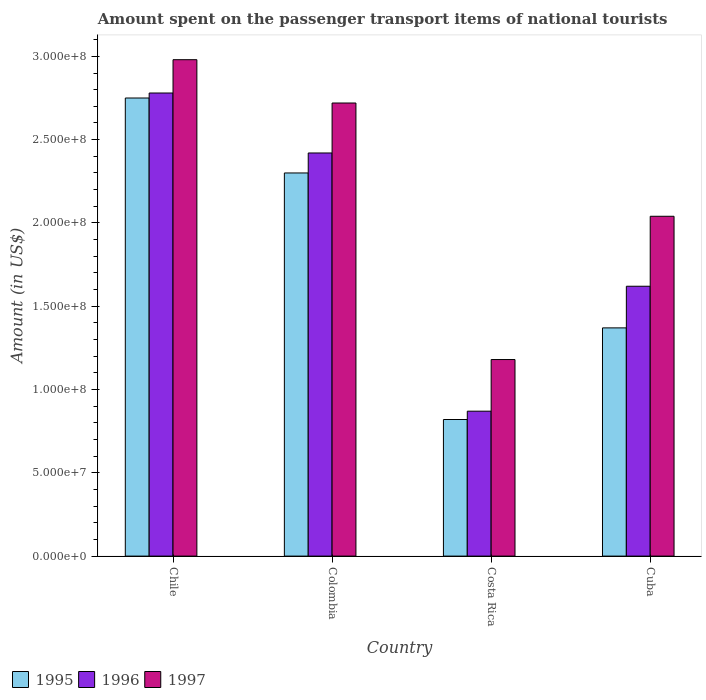How many different coloured bars are there?
Give a very brief answer. 3. How many groups of bars are there?
Make the answer very short. 4. Are the number of bars per tick equal to the number of legend labels?
Make the answer very short. Yes. How many bars are there on the 2nd tick from the left?
Keep it short and to the point. 3. How many bars are there on the 1st tick from the right?
Your answer should be very brief. 3. What is the amount spent on the passenger transport items of national tourists in 1997 in Chile?
Provide a short and direct response. 2.98e+08. Across all countries, what is the maximum amount spent on the passenger transport items of national tourists in 1996?
Your answer should be compact. 2.78e+08. Across all countries, what is the minimum amount spent on the passenger transport items of national tourists in 1995?
Offer a terse response. 8.20e+07. What is the total amount spent on the passenger transport items of national tourists in 1995 in the graph?
Keep it short and to the point. 7.24e+08. What is the difference between the amount spent on the passenger transport items of national tourists in 1995 in Chile and that in Cuba?
Make the answer very short. 1.38e+08. What is the difference between the amount spent on the passenger transport items of national tourists in 1996 in Costa Rica and the amount spent on the passenger transport items of national tourists in 1997 in Cuba?
Your response must be concise. -1.17e+08. What is the average amount spent on the passenger transport items of national tourists in 1996 per country?
Make the answer very short. 1.92e+08. What is the difference between the amount spent on the passenger transport items of national tourists of/in 1997 and amount spent on the passenger transport items of national tourists of/in 1995 in Costa Rica?
Your answer should be very brief. 3.60e+07. In how many countries, is the amount spent on the passenger transport items of national tourists in 1996 greater than 210000000 US$?
Ensure brevity in your answer.  2. What is the ratio of the amount spent on the passenger transport items of national tourists in 1996 in Chile to that in Cuba?
Offer a terse response. 1.72. Is the difference between the amount spent on the passenger transport items of national tourists in 1997 in Costa Rica and Cuba greater than the difference between the amount spent on the passenger transport items of national tourists in 1995 in Costa Rica and Cuba?
Provide a succinct answer. No. What is the difference between the highest and the second highest amount spent on the passenger transport items of national tourists in 1996?
Provide a short and direct response. 1.16e+08. What is the difference between the highest and the lowest amount spent on the passenger transport items of national tourists in 1996?
Keep it short and to the point. 1.91e+08. Is the sum of the amount spent on the passenger transport items of national tourists in 1997 in Chile and Cuba greater than the maximum amount spent on the passenger transport items of national tourists in 1995 across all countries?
Your response must be concise. Yes. How many bars are there?
Ensure brevity in your answer.  12. Are all the bars in the graph horizontal?
Your answer should be very brief. No. What is the difference between two consecutive major ticks on the Y-axis?
Make the answer very short. 5.00e+07. Does the graph contain grids?
Your response must be concise. No. What is the title of the graph?
Provide a succinct answer. Amount spent on the passenger transport items of national tourists. What is the label or title of the Y-axis?
Keep it short and to the point. Amount (in US$). What is the Amount (in US$) in 1995 in Chile?
Offer a very short reply. 2.75e+08. What is the Amount (in US$) in 1996 in Chile?
Make the answer very short. 2.78e+08. What is the Amount (in US$) of 1997 in Chile?
Make the answer very short. 2.98e+08. What is the Amount (in US$) of 1995 in Colombia?
Keep it short and to the point. 2.30e+08. What is the Amount (in US$) in 1996 in Colombia?
Offer a terse response. 2.42e+08. What is the Amount (in US$) of 1997 in Colombia?
Your answer should be very brief. 2.72e+08. What is the Amount (in US$) of 1995 in Costa Rica?
Offer a terse response. 8.20e+07. What is the Amount (in US$) of 1996 in Costa Rica?
Keep it short and to the point. 8.70e+07. What is the Amount (in US$) in 1997 in Costa Rica?
Give a very brief answer. 1.18e+08. What is the Amount (in US$) of 1995 in Cuba?
Make the answer very short. 1.37e+08. What is the Amount (in US$) of 1996 in Cuba?
Your response must be concise. 1.62e+08. What is the Amount (in US$) of 1997 in Cuba?
Your answer should be compact. 2.04e+08. Across all countries, what is the maximum Amount (in US$) in 1995?
Ensure brevity in your answer.  2.75e+08. Across all countries, what is the maximum Amount (in US$) of 1996?
Ensure brevity in your answer.  2.78e+08. Across all countries, what is the maximum Amount (in US$) in 1997?
Keep it short and to the point. 2.98e+08. Across all countries, what is the minimum Amount (in US$) in 1995?
Provide a succinct answer. 8.20e+07. Across all countries, what is the minimum Amount (in US$) in 1996?
Offer a very short reply. 8.70e+07. Across all countries, what is the minimum Amount (in US$) of 1997?
Keep it short and to the point. 1.18e+08. What is the total Amount (in US$) in 1995 in the graph?
Ensure brevity in your answer.  7.24e+08. What is the total Amount (in US$) of 1996 in the graph?
Keep it short and to the point. 7.69e+08. What is the total Amount (in US$) in 1997 in the graph?
Your answer should be compact. 8.92e+08. What is the difference between the Amount (in US$) in 1995 in Chile and that in Colombia?
Keep it short and to the point. 4.50e+07. What is the difference between the Amount (in US$) in 1996 in Chile and that in Colombia?
Make the answer very short. 3.60e+07. What is the difference between the Amount (in US$) of 1997 in Chile and that in Colombia?
Your answer should be compact. 2.60e+07. What is the difference between the Amount (in US$) of 1995 in Chile and that in Costa Rica?
Ensure brevity in your answer.  1.93e+08. What is the difference between the Amount (in US$) in 1996 in Chile and that in Costa Rica?
Offer a very short reply. 1.91e+08. What is the difference between the Amount (in US$) of 1997 in Chile and that in Costa Rica?
Ensure brevity in your answer.  1.80e+08. What is the difference between the Amount (in US$) in 1995 in Chile and that in Cuba?
Offer a very short reply. 1.38e+08. What is the difference between the Amount (in US$) in 1996 in Chile and that in Cuba?
Offer a very short reply. 1.16e+08. What is the difference between the Amount (in US$) of 1997 in Chile and that in Cuba?
Make the answer very short. 9.40e+07. What is the difference between the Amount (in US$) in 1995 in Colombia and that in Costa Rica?
Offer a very short reply. 1.48e+08. What is the difference between the Amount (in US$) in 1996 in Colombia and that in Costa Rica?
Offer a very short reply. 1.55e+08. What is the difference between the Amount (in US$) in 1997 in Colombia and that in Costa Rica?
Keep it short and to the point. 1.54e+08. What is the difference between the Amount (in US$) in 1995 in Colombia and that in Cuba?
Provide a short and direct response. 9.30e+07. What is the difference between the Amount (in US$) in 1996 in Colombia and that in Cuba?
Make the answer very short. 8.00e+07. What is the difference between the Amount (in US$) of 1997 in Colombia and that in Cuba?
Your answer should be compact. 6.80e+07. What is the difference between the Amount (in US$) of 1995 in Costa Rica and that in Cuba?
Your response must be concise. -5.50e+07. What is the difference between the Amount (in US$) of 1996 in Costa Rica and that in Cuba?
Make the answer very short. -7.50e+07. What is the difference between the Amount (in US$) of 1997 in Costa Rica and that in Cuba?
Give a very brief answer. -8.60e+07. What is the difference between the Amount (in US$) in 1995 in Chile and the Amount (in US$) in 1996 in Colombia?
Your answer should be compact. 3.30e+07. What is the difference between the Amount (in US$) of 1995 in Chile and the Amount (in US$) of 1997 in Colombia?
Your answer should be very brief. 3.00e+06. What is the difference between the Amount (in US$) of 1996 in Chile and the Amount (in US$) of 1997 in Colombia?
Make the answer very short. 6.00e+06. What is the difference between the Amount (in US$) of 1995 in Chile and the Amount (in US$) of 1996 in Costa Rica?
Ensure brevity in your answer.  1.88e+08. What is the difference between the Amount (in US$) of 1995 in Chile and the Amount (in US$) of 1997 in Costa Rica?
Give a very brief answer. 1.57e+08. What is the difference between the Amount (in US$) of 1996 in Chile and the Amount (in US$) of 1997 in Costa Rica?
Keep it short and to the point. 1.60e+08. What is the difference between the Amount (in US$) in 1995 in Chile and the Amount (in US$) in 1996 in Cuba?
Your answer should be very brief. 1.13e+08. What is the difference between the Amount (in US$) in 1995 in Chile and the Amount (in US$) in 1997 in Cuba?
Provide a short and direct response. 7.10e+07. What is the difference between the Amount (in US$) of 1996 in Chile and the Amount (in US$) of 1997 in Cuba?
Your answer should be compact. 7.40e+07. What is the difference between the Amount (in US$) of 1995 in Colombia and the Amount (in US$) of 1996 in Costa Rica?
Give a very brief answer. 1.43e+08. What is the difference between the Amount (in US$) of 1995 in Colombia and the Amount (in US$) of 1997 in Costa Rica?
Your answer should be compact. 1.12e+08. What is the difference between the Amount (in US$) in 1996 in Colombia and the Amount (in US$) in 1997 in Costa Rica?
Ensure brevity in your answer.  1.24e+08. What is the difference between the Amount (in US$) of 1995 in Colombia and the Amount (in US$) of 1996 in Cuba?
Ensure brevity in your answer.  6.80e+07. What is the difference between the Amount (in US$) in 1995 in Colombia and the Amount (in US$) in 1997 in Cuba?
Keep it short and to the point. 2.60e+07. What is the difference between the Amount (in US$) of 1996 in Colombia and the Amount (in US$) of 1997 in Cuba?
Your answer should be compact. 3.80e+07. What is the difference between the Amount (in US$) of 1995 in Costa Rica and the Amount (in US$) of 1996 in Cuba?
Make the answer very short. -8.00e+07. What is the difference between the Amount (in US$) of 1995 in Costa Rica and the Amount (in US$) of 1997 in Cuba?
Keep it short and to the point. -1.22e+08. What is the difference between the Amount (in US$) of 1996 in Costa Rica and the Amount (in US$) of 1997 in Cuba?
Provide a succinct answer. -1.17e+08. What is the average Amount (in US$) in 1995 per country?
Provide a succinct answer. 1.81e+08. What is the average Amount (in US$) of 1996 per country?
Provide a succinct answer. 1.92e+08. What is the average Amount (in US$) in 1997 per country?
Your response must be concise. 2.23e+08. What is the difference between the Amount (in US$) of 1995 and Amount (in US$) of 1997 in Chile?
Keep it short and to the point. -2.30e+07. What is the difference between the Amount (in US$) of 1996 and Amount (in US$) of 1997 in Chile?
Ensure brevity in your answer.  -2.00e+07. What is the difference between the Amount (in US$) of 1995 and Amount (in US$) of 1996 in Colombia?
Give a very brief answer. -1.20e+07. What is the difference between the Amount (in US$) of 1995 and Amount (in US$) of 1997 in Colombia?
Provide a succinct answer. -4.20e+07. What is the difference between the Amount (in US$) of 1996 and Amount (in US$) of 1997 in Colombia?
Make the answer very short. -3.00e+07. What is the difference between the Amount (in US$) of 1995 and Amount (in US$) of 1996 in Costa Rica?
Ensure brevity in your answer.  -5.00e+06. What is the difference between the Amount (in US$) of 1995 and Amount (in US$) of 1997 in Costa Rica?
Keep it short and to the point. -3.60e+07. What is the difference between the Amount (in US$) in 1996 and Amount (in US$) in 1997 in Costa Rica?
Your answer should be compact. -3.10e+07. What is the difference between the Amount (in US$) in 1995 and Amount (in US$) in 1996 in Cuba?
Offer a terse response. -2.50e+07. What is the difference between the Amount (in US$) of 1995 and Amount (in US$) of 1997 in Cuba?
Offer a terse response. -6.70e+07. What is the difference between the Amount (in US$) in 1996 and Amount (in US$) in 1997 in Cuba?
Your response must be concise. -4.20e+07. What is the ratio of the Amount (in US$) of 1995 in Chile to that in Colombia?
Give a very brief answer. 1.2. What is the ratio of the Amount (in US$) in 1996 in Chile to that in Colombia?
Make the answer very short. 1.15. What is the ratio of the Amount (in US$) in 1997 in Chile to that in Colombia?
Make the answer very short. 1.1. What is the ratio of the Amount (in US$) in 1995 in Chile to that in Costa Rica?
Your response must be concise. 3.35. What is the ratio of the Amount (in US$) of 1996 in Chile to that in Costa Rica?
Ensure brevity in your answer.  3.2. What is the ratio of the Amount (in US$) of 1997 in Chile to that in Costa Rica?
Provide a succinct answer. 2.53. What is the ratio of the Amount (in US$) of 1995 in Chile to that in Cuba?
Provide a short and direct response. 2.01. What is the ratio of the Amount (in US$) of 1996 in Chile to that in Cuba?
Give a very brief answer. 1.72. What is the ratio of the Amount (in US$) of 1997 in Chile to that in Cuba?
Keep it short and to the point. 1.46. What is the ratio of the Amount (in US$) in 1995 in Colombia to that in Costa Rica?
Your answer should be very brief. 2.8. What is the ratio of the Amount (in US$) in 1996 in Colombia to that in Costa Rica?
Give a very brief answer. 2.78. What is the ratio of the Amount (in US$) in 1997 in Colombia to that in Costa Rica?
Ensure brevity in your answer.  2.31. What is the ratio of the Amount (in US$) of 1995 in Colombia to that in Cuba?
Provide a short and direct response. 1.68. What is the ratio of the Amount (in US$) in 1996 in Colombia to that in Cuba?
Make the answer very short. 1.49. What is the ratio of the Amount (in US$) of 1995 in Costa Rica to that in Cuba?
Your answer should be compact. 0.6. What is the ratio of the Amount (in US$) in 1996 in Costa Rica to that in Cuba?
Provide a succinct answer. 0.54. What is the ratio of the Amount (in US$) in 1997 in Costa Rica to that in Cuba?
Give a very brief answer. 0.58. What is the difference between the highest and the second highest Amount (in US$) in 1995?
Offer a very short reply. 4.50e+07. What is the difference between the highest and the second highest Amount (in US$) of 1996?
Your response must be concise. 3.60e+07. What is the difference between the highest and the second highest Amount (in US$) in 1997?
Offer a terse response. 2.60e+07. What is the difference between the highest and the lowest Amount (in US$) in 1995?
Provide a short and direct response. 1.93e+08. What is the difference between the highest and the lowest Amount (in US$) in 1996?
Your response must be concise. 1.91e+08. What is the difference between the highest and the lowest Amount (in US$) of 1997?
Keep it short and to the point. 1.80e+08. 